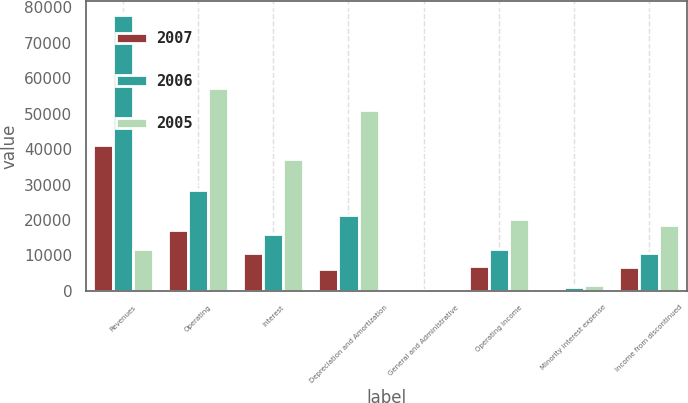<chart> <loc_0><loc_0><loc_500><loc_500><stacked_bar_chart><ecel><fcel>Revenues<fcel>Operating<fcel>Interest<fcel>Depreciation and Amortization<fcel>General and Administrative<fcel>Operating Income<fcel>Minority interest expense<fcel>Income from discontinued<nl><fcel>2007<fcel>41117<fcel>17187<fcel>10666<fcel>6068<fcel>47<fcel>7149<fcel>443<fcel>6706<nl><fcel>2006<fcel>77975<fcel>28613<fcel>16022<fcel>21529<fcel>119<fcel>11692<fcel>1041<fcel>10651<nl><fcel>2005<fcel>11692<fcel>57335<fcel>37223<fcel>51089<fcel>257<fcel>20331<fcel>1777<fcel>18554<nl></chart> 